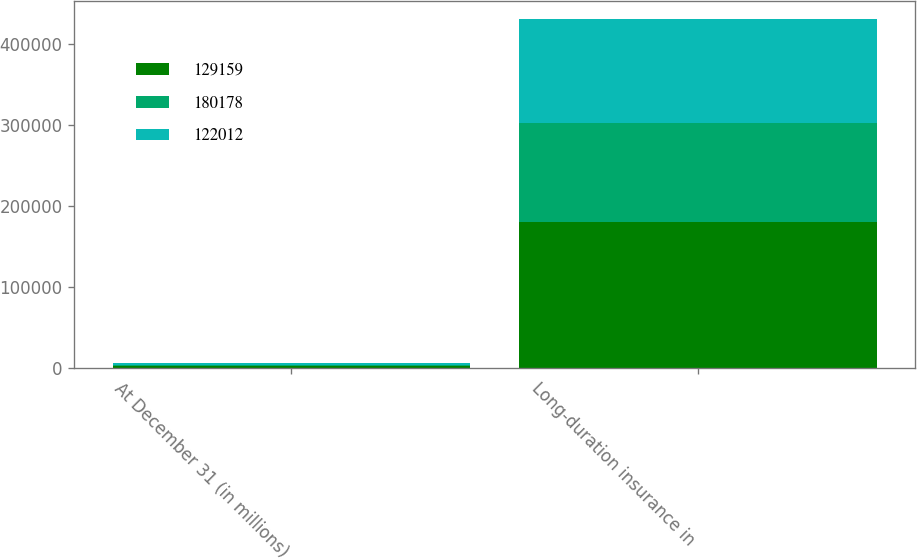Convert chart. <chart><loc_0><loc_0><loc_500><loc_500><stacked_bar_chart><ecel><fcel>At December 31 (in millions)<fcel>Long-duration insurance in<nl><fcel>129159<fcel>2014<fcel>180178<nl><fcel>180178<fcel>2013<fcel>122012<nl><fcel>122012<fcel>2012<fcel>129159<nl></chart> 